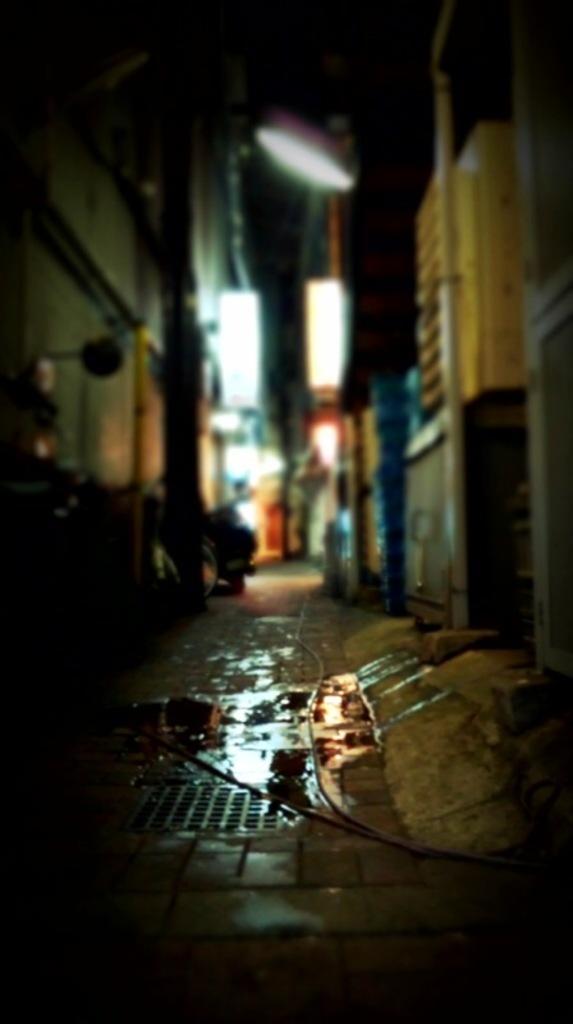How would you summarize this image in a sentence or two? In this picture there are wires on the floor and there is light at the top and in the center of the image, it seems to be there are shops in the image, the area of the image is blur. 